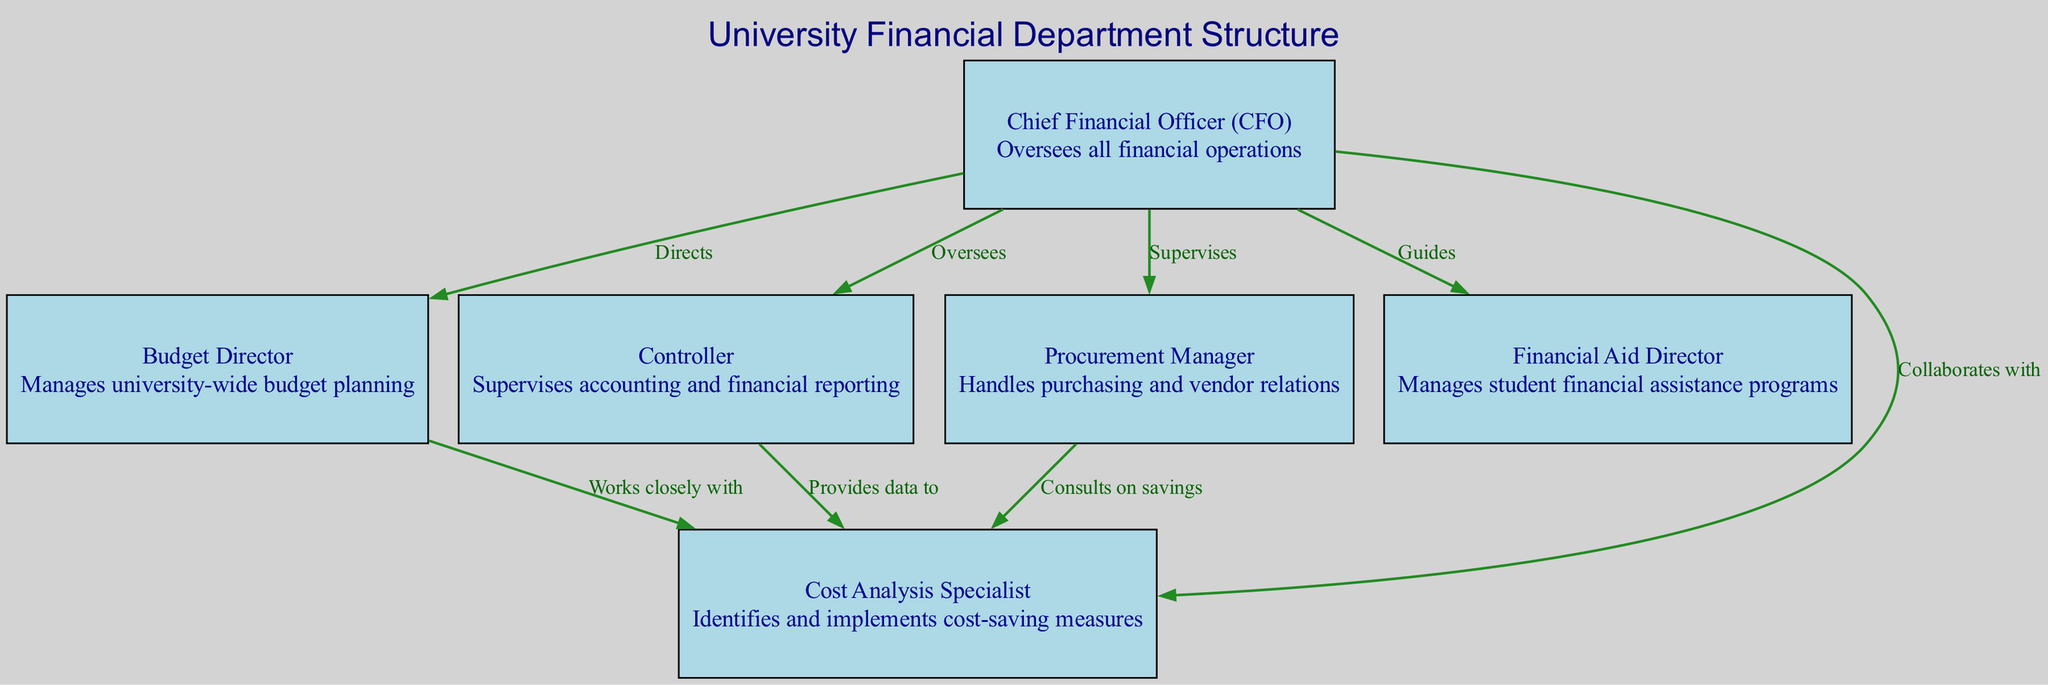What is the role of the Chief Financial Officer? The Chief Financial Officer oversees all financial operations as indicated in the diagram.
Answer: Oversees all financial operations How many nodes are present in the diagram? The diagram lists 6 nodes representing different roles in the financial department. Counting these gives a total of 6 nodes.
Answer: 6 Who does the Budget Director work closely with? According to the diagram, the Budget Director works closely with the Cost Analysis Specialist. This is indicated by a direct edge labeled "Works closely with".
Answer: Cost Analysis Specialist What is the responsibility of the Procurement Manager? The Procurement Manager handles purchasing and vendor relations as described in the node’s description within the diagram.
Answer: Handles purchasing and vendor relations Which role provides data to the Cost Analysis Specialist? The diagram specifies that the Controller provides data to the Cost Analysis Specialist, indicating a direct connection with this role.
Answer: Controller How many edges connect the Chief Financial Officer to other roles? The diagram shows that the Chief Financial Officer connects to 5 other roles, represented by outgoing edges from the CFO node.
Answer: 5 What type of relationship exists between the Procurement Manager and the Cost Analysis Specialist? The relationship is described in the diagram where the Procurement Manager consults on savings with the Cost Analysis Specialist, indicating a collaborative interaction.
Answer: Consults on savings In regard to supervision, which position does the CFO oversee? The Chief Financial Officer oversees the Controller, Budget Director, and Procurement Manager, as indicated by edges labeled "Oversees" and "Directs".
Answer: Controller, Budget Director, Procurement Manager What is the main focus of the Cost Analysis Specialist? The Cost Analysis Specialist identifies and implements cost-saving measures, which is clearly defined in the description provided in the diagram.
Answer: Identifies and implements cost-saving measures 